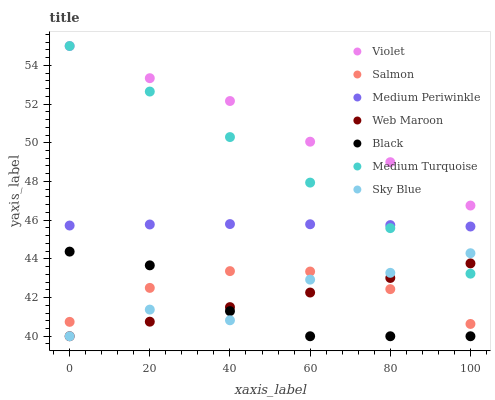Does Black have the minimum area under the curve?
Answer yes or no. Yes. Does Violet have the maximum area under the curve?
Answer yes or no. Yes. Does Salmon have the minimum area under the curve?
Answer yes or no. No. Does Salmon have the maximum area under the curve?
Answer yes or no. No. Is Web Maroon the smoothest?
Answer yes or no. Yes. Is Sky Blue the roughest?
Answer yes or no. Yes. Is Salmon the smoothest?
Answer yes or no. No. Is Salmon the roughest?
Answer yes or no. No. Does Web Maroon have the lowest value?
Answer yes or no. Yes. Does Salmon have the lowest value?
Answer yes or no. No. Does Violet have the highest value?
Answer yes or no. Yes. Does Medium Periwinkle have the highest value?
Answer yes or no. No. Is Sky Blue less than Violet?
Answer yes or no. Yes. Is Medium Periwinkle greater than Black?
Answer yes or no. Yes. Does Web Maroon intersect Medium Turquoise?
Answer yes or no. Yes. Is Web Maroon less than Medium Turquoise?
Answer yes or no. No. Is Web Maroon greater than Medium Turquoise?
Answer yes or no. No. Does Sky Blue intersect Violet?
Answer yes or no. No. 